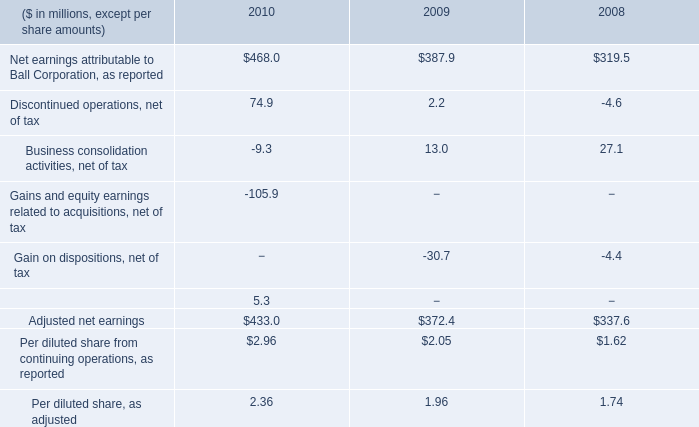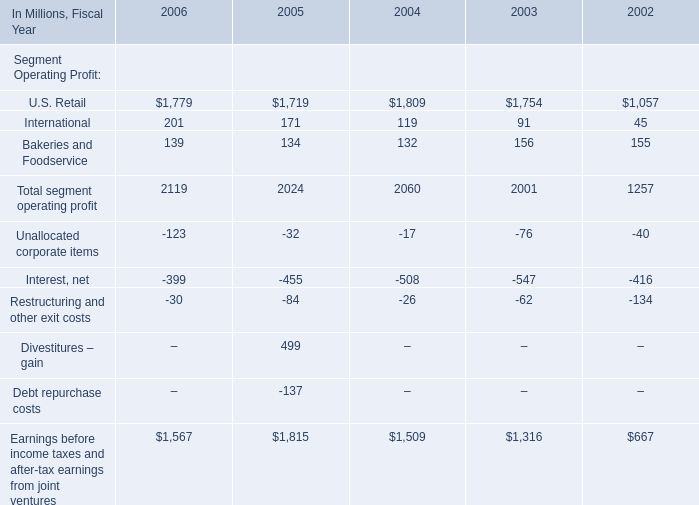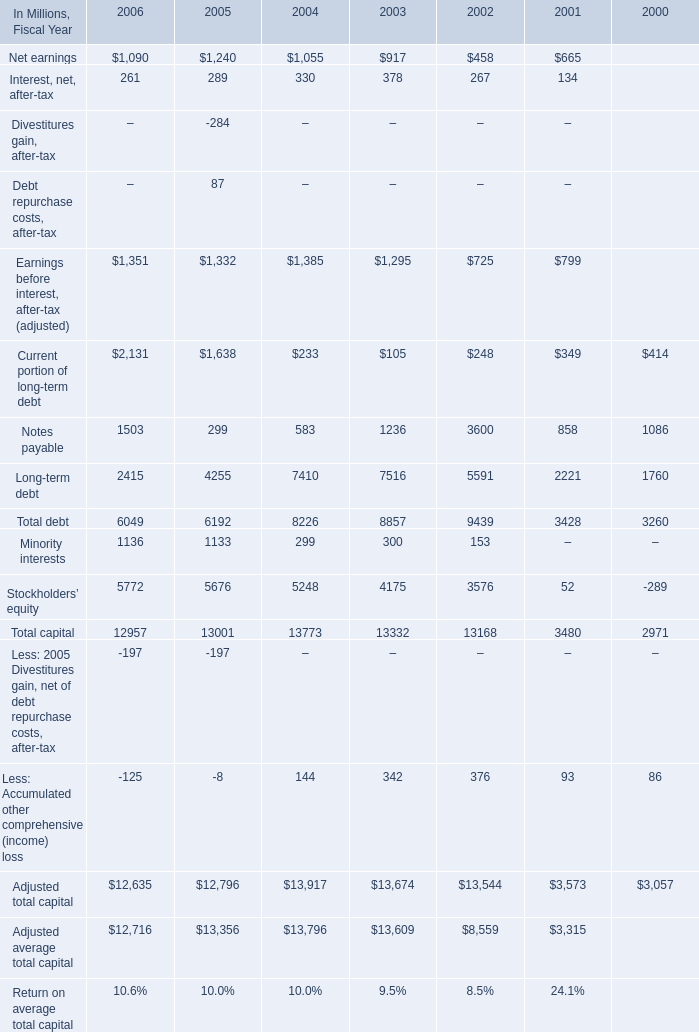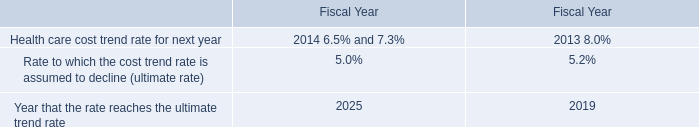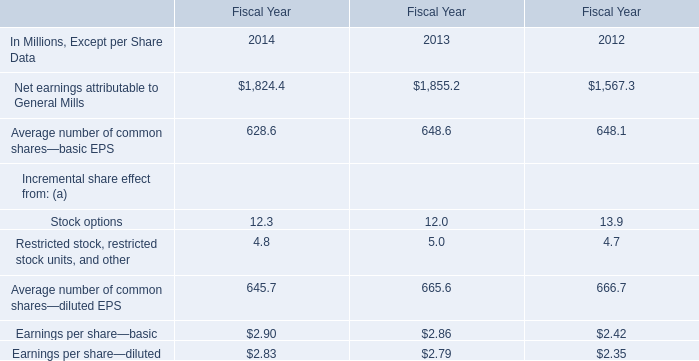In the Fiscal Year where Total segment operating profit is between 2030 Million and 2070 Million, what's the Segment Operating Profit in terms of Bakeries and Foodservice? (in million) 
Answer: 132. 